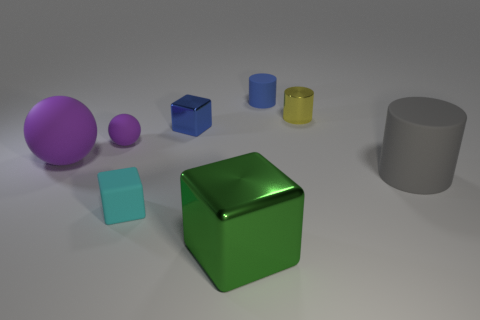Subtract all blue blocks. How many blocks are left? 2 Subtract all blue cylinders. How many cylinders are left? 2 Subtract all spheres. How many objects are left? 6 Subtract 1 balls. How many balls are left? 1 Add 1 tiny blue cylinders. How many objects exist? 9 Subtract 1 yellow cylinders. How many objects are left? 7 Subtract all gray spheres. Subtract all gray cubes. How many spheres are left? 2 Subtract all gray spheres. How many brown cubes are left? 0 Subtract all tiny metal cubes. Subtract all tiny blue metallic blocks. How many objects are left? 6 Add 6 large metal things. How many large metal things are left? 7 